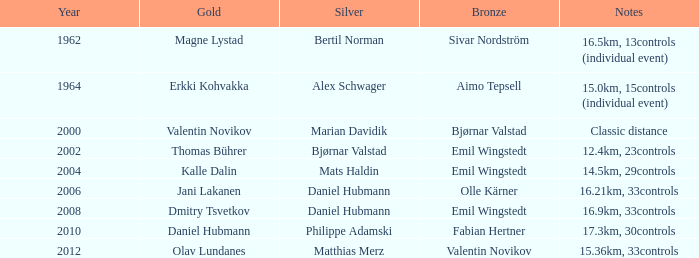WHAT YEAR HAS A SILVER FOR MATTHIAS MERZ? 2012.0. 